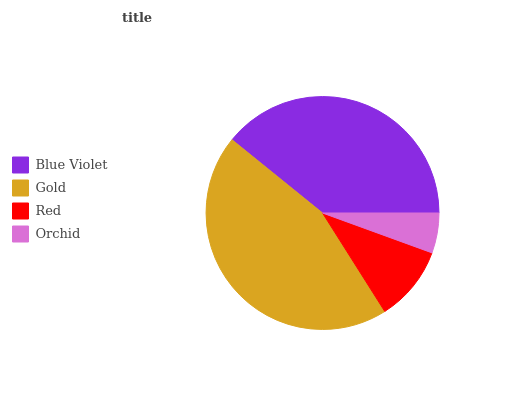Is Orchid the minimum?
Answer yes or no. Yes. Is Gold the maximum?
Answer yes or no. Yes. Is Red the minimum?
Answer yes or no. No. Is Red the maximum?
Answer yes or no. No. Is Gold greater than Red?
Answer yes or no. Yes. Is Red less than Gold?
Answer yes or no. Yes. Is Red greater than Gold?
Answer yes or no. No. Is Gold less than Red?
Answer yes or no. No. Is Blue Violet the high median?
Answer yes or no. Yes. Is Red the low median?
Answer yes or no. Yes. Is Orchid the high median?
Answer yes or no. No. Is Blue Violet the low median?
Answer yes or no. No. 